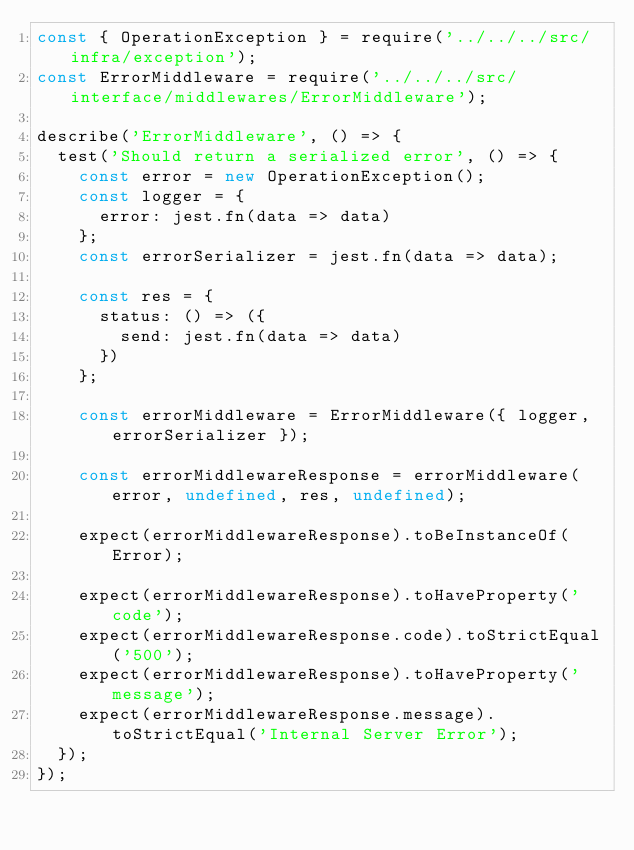<code> <loc_0><loc_0><loc_500><loc_500><_JavaScript_>const { OperationException } = require('../../../src/infra/exception');
const ErrorMiddleware = require('../../../src/interface/middlewares/ErrorMiddleware');

describe('ErrorMiddleware', () => {
  test('Should return a serialized error', () => {
    const error = new OperationException();
    const logger = {
      error: jest.fn(data => data)
    };
    const errorSerializer = jest.fn(data => data);

    const res = {
      status: () => ({
        send: jest.fn(data => data)
      })
    };

    const errorMiddleware = ErrorMiddleware({ logger, errorSerializer });

    const errorMiddlewareResponse = errorMiddleware(error, undefined, res, undefined);

    expect(errorMiddlewareResponse).toBeInstanceOf(Error);

    expect(errorMiddlewareResponse).toHaveProperty('code');
    expect(errorMiddlewareResponse.code).toStrictEqual('500');
    expect(errorMiddlewareResponse).toHaveProperty('message');
    expect(errorMiddlewareResponse.message).toStrictEqual('Internal Server Error');
  });
});
</code> 